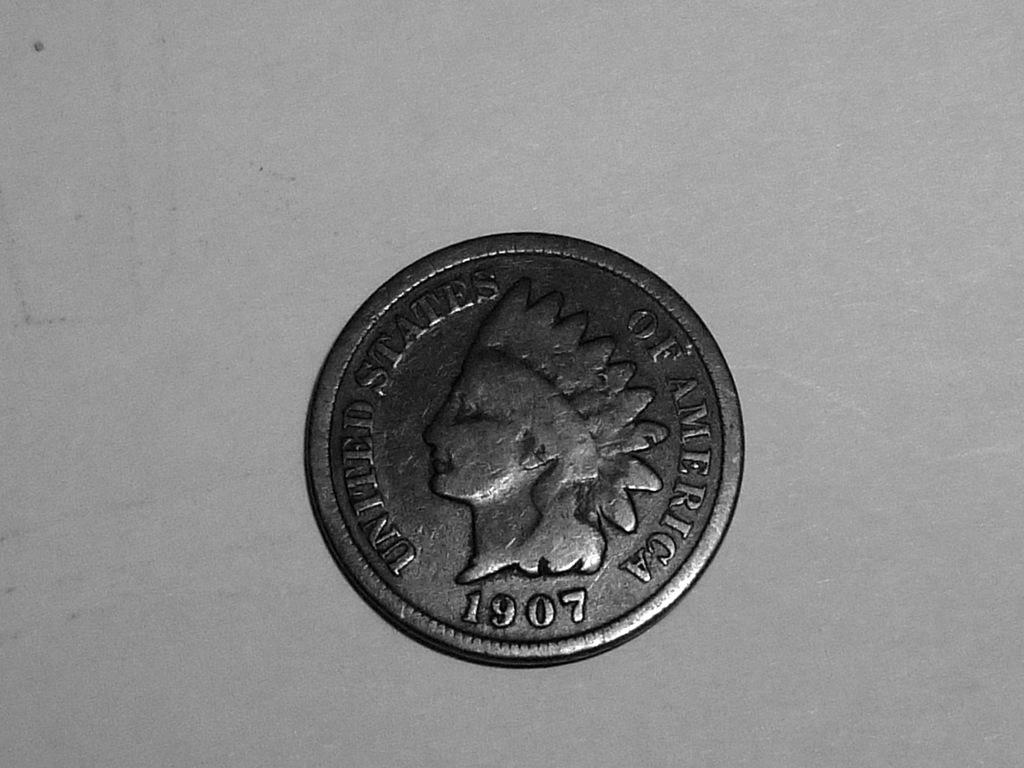<image>
Create a compact narrative representing the image presented. A United States of America coin from 1907. 